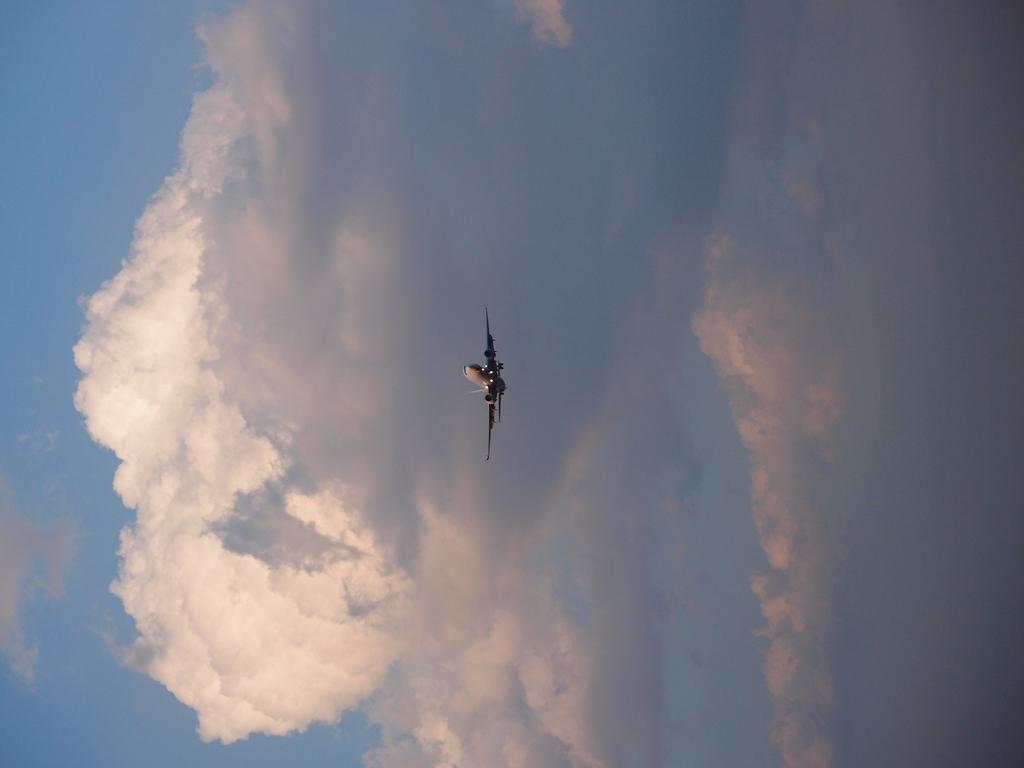Can you describe this image briefly? In this picture we can see an airplane flying in the air and in the background we can see the sky with clouds. 